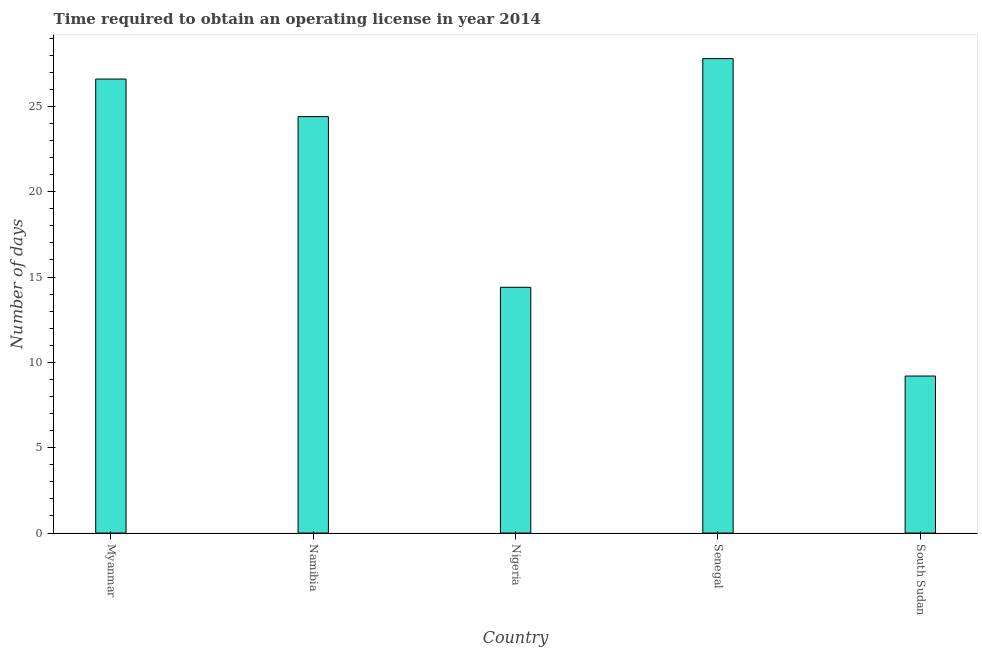Does the graph contain grids?
Give a very brief answer. No. What is the title of the graph?
Ensure brevity in your answer.  Time required to obtain an operating license in year 2014. What is the label or title of the Y-axis?
Ensure brevity in your answer.  Number of days. What is the number of days to obtain operating license in Namibia?
Give a very brief answer. 24.4. Across all countries, what is the maximum number of days to obtain operating license?
Offer a very short reply. 27.8. Across all countries, what is the minimum number of days to obtain operating license?
Give a very brief answer. 9.2. In which country was the number of days to obtain operating license maximum?
Your answer should be very brief. Senegal. In which country was the number of days to obtain operating license minimum?
Your answer should be very brief. South Sudan. What is the sum of the number of days to obtain operating license?
Your answer should be very brief. 102.4. What is the difference between the number of days to obtain operating license in Myanmar and Namibia?
Provide a short and direct response. 2.2. What is the average number of days to obtain operating license per country?
Provide a short and direct response. 20.48. What is the median number of days to obtain operating license?
Offer a terse response. 24.4. What is the ratio of the number of days to obtain operating license in Senegal to that in South Sudan?
Offer a terse response. 3.02. Is the number of days to obtain operating license in Namibia less than that in Nigeria?
Keep it short and to the point. No. Is the sum of the number of days to obtain operating license in Senegal and South Sudan greater than the maximum number of days to obtain operating license across all countries?
Your answer should be very brief. Yes. What is the difference between the highest and the lowest number of days to obtain operating license?
Offer a very short reply. 18.6. In how many countries, is the number of days to obtain operating license greater than the average number of days to obtain operating license taken over all countries?
Provide a succinct answer. 3. How many bars are there?
Ensure brevity in your answer.  5. How many countries are there in the graph?
Provide a succinct answer. 5. Are the values on the major ticks of Y-axis written in scientific E-notation?
Give a very brief answer. No. What is the Number of days in Myanmar?
Your answer should be very brief. 26.6. What is the Number of days in Namibia?
Your answer should be compact. 24.4. What is the Number of days of Nigeria?
Your response must be concise. 14.4. What is the Number of days of Senegal?
Your answer should be very brief. 27.8. What is the difference between the Number of days in Myanmar and Namibia?
Keep it short and to the point. 2.2. What is the difference between the Number of days in Myanmar and South Sudan?
Keep it short and to the point. 17.4. What is the difference between the Number of days in Namibia and Nigeria?
Give a very brief answer. 10. What is the difference between the Number of days in Namibia and South Sudan?
Give a very brief answer. 15.2. What is the difference between the Number of days in Nigeria and Senegal?
Your answer should be compact. -13.4. What is the difference between the Number of days in Nigeria and South Sudan?
Your response must be concise. 5.2. What is the ratio of the Number of days in Myanmar to that in Namibia?
Your answer should be very brief. 1.09. What is the ratio of the Number of days in Myanmar to that in Nigeria?
Keep it short and to the point. 1.85. What is the ratio of the Number of days in Myanmar to that in South Sudan?
Your answer should be very brief. 2.89. What is the ratio of the Number of days in Namibia to that in Nigeria?
Offer a very short reply. 1.69. What is the ratio of the Number of days in Namibia to that in Senegal?
Provide a succinct answer. 0.88. What is the ratio of the Number of days in Namibia to that in South Sudan?
Provide a short and direct response. 2.65. What is the ratio of the Number of days in Nigeria to that in Senegal?
Your response must be concise. 0.52. What is the ratio of the Number of days in Nigeria to that in South Sudan?
Provide a short and direct response. 1.56. What is the ratio of the Number of days in Senegal to that in South Sudan?
Provide a succinct answer. 3.02. 